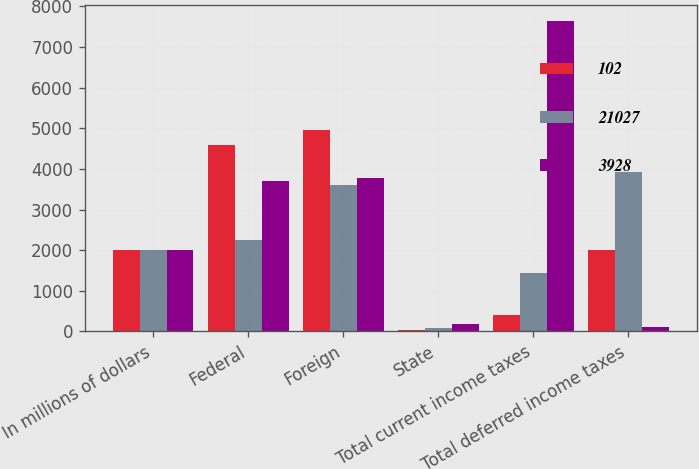Convert chart. <chart><loc_0><loc_0><loc_500><loc_500><stacked_bar_chart><ecel><fcel>In millions of dollars<fcel>Federal<fcel>Foreign<fcel>State<fcel>Total current income taxes<fcel>Total deferred income taxes<nl><fcel>102<fcel>2008<fcel>4582<fcel>4968<fcel>29<fcel>415<fcel>2008<nl><fcel>21027<fcel>2007<fcel>2260<fcel>3615<fcel>75<fcel>1430<fcel>3928<nl><fcel>3928<fcel>2006<fcel>3703<fcel>3766<fcel>178<fcel>7647<fcel>102<nl></chart> 